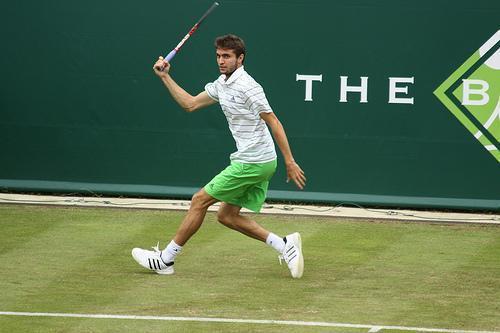How many people are playing football?
Give a very brief answer. 0. 